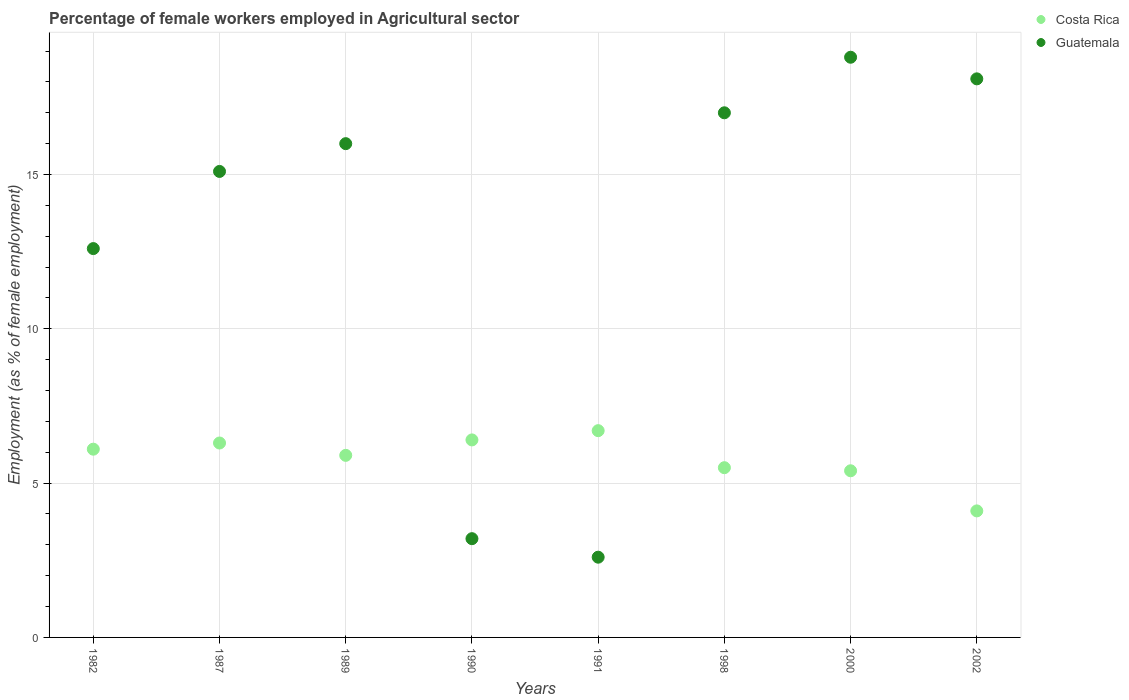What is the percentage of females employed in Agricultural sector in Costa Rica in 1982?
Your answer should be very brief. 6.1. Across all years, what is the maximum percentage of females employed in Agricultural sector in Guatemala?
Keep it short and to the point. 18.8. Across all years, what is the minimum percentage of females employed in Agricultural sector in Costa Rica?
Make the answer very short. 4.1. What is the total percentage of females employed in Agricultural sector in Costa Rica in the graph?
Your answer should be very brief. 46.4. What is the difference between the percentage of females employed in Agricultural sector in Costa Rica in 1987 and that in 1991?
Your answer should be compact. -0.4. What is the difference between the percentage of females employed in Agricultural sector in Guatemala in 1991 and the percentage of females employed in Agricultural sector in Costa Rica in 2000?
Offer a terse response. -2.8. What is the average percentage of females employed in Agricultural sector in Guatemala per year?
Your response must be concise. 12.93. In the year 1990, what is the difference between the percentage of females employed in Agricultural sector in Guatemala and percentage of females employed in Agricultural sector in Costa Rica?
Provide a succinct answer. -3.2. In how many years, is the percentage of females employed in Agricultural sector in Guatemala greater than 6 %?
Give a very brief answer. 6. What is the ratio of the percentage of females employed in Agricultural sector in Costa Rica in 1990 to that in 2000?
Provide a succinct answer. 1.19. What is the difference between the highest and the second highest percentage of females employed in Agricultural sector in Guatemala?
Offer a very short reply. 0.7. What is the difference between the highest and the lowest percentage of females employed in Agricultural sector in Guatemala?
Your answer should be compact. 16.2. In how many years, is the percentage of females employed in Agricultural sector in Costa Rica greater than the average percentage of females employed in Agricultural sector in Costa Rica taken over all years?
Keep it short and to the point. 5. Is the sum of the percentage of females employed in Agricultural sector in Costa Rica in 1991 and 2002 greater than the maximum percentage of females employed in Agricultural sector in Guatemala across all years?
Provide a succinct answer. No. Does the percentage of females employed in Agricultural sector in Guatemala monotonically increase over the years?
Offer a very short reply. No. Is the percentage of females employed in Agricultural sector in Costa Rica strictly less than the percentage of females employed in Agricultural sector in Guatemala over the years?
Make the answer very short. No. Does the graph contain grids?
Offer a very short reply. Yes. How many legend labels are there?
Your response must be concise. 2. What is the title of the graph?
Keep it short and to the point. Percentage of female workers employed in Agricultural sector. What is the label or title of the X-axis?
Keep it short and to the point. Years. What is the label or title of the Y-axis?
Make the answer very short. Employment (as % of female employment). What is the Employment (as % of female employment) in Costa Rica in 1982?
Offer a terse response. 6.1. What is the Employment (as % of female employment) in Guatemala in 1982?
Offer a terse response. 12.6. What is the Employment (as % of female employment) of Costa Rica in 1987?
Offer a very short reply. 6.3. What is the Employment (as % of female employment) of Guatemala in 1987?
Your answer should be compact. 15.1. What is the Employment (as % of female employment) in Costa Rica in 1989?
Your answer should be very brief. 5.9. What is the Employment (as % of female employment) of Guatemala in 1989?
Provide a succinct answer. 16. What is the Employment (as % of female employment) of Costa Rica in 1990?
Keep it short and to the point. 6.4. What is the Employment (as % of female employment) of Guatemala in 1990?
Ensure brevity in your answer.  3.2. What is the Employment (as % of female employment) in Costa Rica in 1991?
Ensure brevity in your answer.  6.7. What is the Employment (as % of female employment) of Guatemala in 1991?
Ensure brevity in your answer.  2.6. What is the Employment (as % of female employment) in Costa Rica in 1998?
Offer a very short reply. 5.5. What is the Employment (as % of female employment) in Costa Rica in 2000?
Make the answer very short. 5.4. What is the Employment (as % of female employment) in Guatemala in 2000?
Provide a short and direct response. 18.8. What is the Employment (as % of female employment) of Costa Rica in 2002?
Your answer should be very brief. 4.1. What is the Employment (as % of female employment) of Guatemala in 2002?
Provide a short and direct response. 18.1. Across all years, what is the maximum Employment (as % of female employment) in Costa Rica?
Offer a very short reply. 6.7. Across all years, what is the maximum Employment (as % of female employment) of Guatemala?
Provide a succinct answer. 18.8. Across all years, what is the minimum Employment (as % of female employment) in Costa Rica?
Give a very brief answer. 4.1. Across all years, what is the minimum Employment (as % of female employment) in Guatemala?
Offer a terse response. 2.6. What is the total Employment (as % of female employment) of Costa Rica in the graph?
Ensure brevity in your answer.  46.4. What is the total Employment (as % of female employment) in Guatemala in the graph?
Provide a short and direct response. 103.4. What is the difference between the Employment (as % of female employment) in Guatemala in 1982 and that in 1987?
Give a very brief answer. -2.5. What is the difference between the Employment (as % of female employment) in Costa Rica in 1982 and that in 1990?
Offer a very short reply. -0.3. What is the difference between the Employment (as % of female employment) of Guatemala in 1982 and that in 1990?
Ensure brevity in your answer.  9.4. What is the difference between the Employment (as % of female employment) in Costa Rica in 1982 and that in 1991?
Offer a terse response. -0.6. What is the difference between the Employment (as % of female employment) in Costa Rica in 1982 and that in 1998?
Offer a terse response. 0.6. What is the difference between the Employment (as % of female employment) in Costa Rica in 1982 and that in 2000?
Ensure brevity in your answer.  0.7. What is the difference between the Employment (as % of female employment) of Guatemala in 1982 and that in 2002?
Offer a terse response. -5.5. What is the difference between the Employment (as % of female employment) in Guatemala in 1987 and that in 1989?
Provide a succinct answer. -0.9. What is the difference between the Employment (as % of female employment) of Costa Rica in 1987 and that in 1990?
Your answer should be very brief. -0.1. What is the difference between the Employment (as % of female employment) of Costa Rica in 1987 and that in 1991?
Make the answer very short. -0.4. What is the difference between the Employment (as % of female employment) in Guatemala in 1987 and that in 1991?
Offer a very short reply. 12.5. What is the difference between the Employment (as % of female employment) in Costa Rica in 1987 and that in 1998?
Make the answer very short. 0.8. What is the difference between the Employment (as % of female employment) of Guatemala in 1987 and that in 1998?
Keep it short and to the point. -1.9. What is the difference between the Employment (as % of female employment) of Costa Rica in 1987 and that in 2000?
Your answer should be compact. 0.9. What is the difference between the Employment (as % of female employment) of Guatemala in 1987 and that in 2000?
Give a very brief answer. -3.7. What is the difference between the Employment (as % of female employment) in Costa Rica in 1987 and that in 2002?
Provide a succinct answer. 2.2. What is the difference between the Employment (as % of female employment) of Costa Rica in 1989 and that in 1990?
Your response must be concise. -0.5. What is the difference between the Employment (as % of female employment) in Costa Rica in 1989 and that in 1991?
Offer a very short reply. -0.8. What is the difference between the Employment (as % of female employment) of Guatemala in 1989 and that in 1991?
Keep it short and to the point. 13.4. What is the difference between the Employment (as % of female employment) in Costa Rica in 1989 and that in 2000?
Provide a short and direct response. 0.5. What is the difference between the Employment (as % of female employment) of Guatemala in 1989 and that in 2000?
Keep it short and to the point. -2.8. What is the difference between the Employment (as % of female employment) in Costa Rica in 1989 and that in 2002?
Your response must be concise. 1.8. What is the difference between the Employment (as % of female employment) of Guatemala in 1989 and that in 2002?
Make the answer very short. -2.1. What is the difference between the Employment (as % of female employment) in Costa Rica in 1990 and that in 1998?
Ensure brevity in your answer.  0.9. What is the difference between the Employment (as % of female employment) of Guatemala in 1990 and that in 1998?
Your answer should be compact. -13.8. What is the difference between the Employment (as % of female employment) of Costa Rica in 1990 and that in 2000?
Offer a terse response. 1. What is the difference between the Employment (as % of female employment) in Guatemala in 1990 and that in 2000?
Offer a terse response. -15.6. What is the difference between the Employment (as % of female employment) in Guatemala in 1990 and that in 2002?
Your answer should be compact. -14.9. What is the difference between the Employment (as % of female employment) of Costa Rica in 1991 and that in 1998?
Your answer should be compact. 1.2. What is the difference between the Employment (as % of female employment) of Guatemala in 1991 and that in 1998?
Ensure brevity in your answer.  -14.4. What is the difference between the Employment (as % of female employment) in Costa Rica in 1991 and that in 2000?
Offer a very short reply. 1.3. What is the difference between the Employment (as % of female employment) in Guatemala in 1991 and that in 2000?
Your answer should be very brief. -16.2. What is the difference between the Employment (as % of female employment) of Costa Rica in 1991 and that in 2002?
Offer a very short reply. 2.6. What is the difference between the Employment (as % of female employment) in Guatemala in 1991 and that in 2002?
Your response must be concise. -15.5. What is the difference between the Employment (as % of female employment) of Costa Rica in 1998 and that in 2000?
Your response must be concise. 0.1. What is the difference between the Employment (as % of female employment) in Guatemala in 1998 and that in 2000?
Give a very brief answer. -1.8. What is the difference between the Employment (as % of female employment) of Costa Rica in 2000 and that in 2002?
Provide a short and direct response. 1.3. What is the difference between the Employment (as % of female employment) in Costa Rica in 1982 and the Employment (as % of female employment) in Guatemala in 1987?
Your answer should be compact. -9. What is the difference between the Employment (as % of female employment) of Costa Rica in 1982 and the Employment (as % of female employment) of Guatemala in 1989?
Give a very brief answer. -9.9. What is the difference between the Employment (as % of female employment) of Costa Rica in 1982 and the Employment (as % of female employment) of Guatemala in 1991?
Offer a very short reply. 3.5. What is the difference between the Employment (as % of female employment) of Costa Rica in 1982 and the Employment (as % of female employment) of Guatemala in 1998?
Your answer should be very brief. -10.9. What is the difference between the Employment (as % of female employment) in Costa Rica in 1982 and the Employment (as % of female employment) in Guatemala in 2000?
Your response must be concise. -12.7. What is the difference between the Employment (as % of female employment) of Costa Rica in 1982 and the Employment (as % of female employment) of Guatemala in 2002?
Make the answer very short. -12. What is the difference between the Employment (as % of female employment) in Costa Rica in 1987 and the Employment (as % of female employment) in Guatemala in 1989?
Your answer should be very brief. -9.7. What is the difference between the Employment (as % of female employment) in Costa Rica in 1987 and the Employment (as % of female employment) in Guatemala in 1990?
Your response must be concise. 3.1. What is the difference between the Employment (as % of female employment) of Costa Rica in 1989 and the Employment (as % of female employment) of Guatemala in 1991?
Give a very brief answer. 3.3. What is the difference between the Employment (as % of female employment) of Costa Rica in 1990 and the Employment (as % of female employment) of Guatemala in 2000?
Provide a short and direct response. -12.4. What is the difference between the Employment (as % of female employment) of Costa Rica in 1990 and the Employment (as % of female employment) of Guatemala in 2002?
Keep it short and to the point. -11.7. What is the difference between the Employment (as % of female employment) in Costa Rica in 1991 and the Employment (as % of female employment) in Guatemala in 1998?
Keep it short and to the point. -10.3. What is the average Employment (as % of female employment) in Guatemala per year?
Ensure brevity in your answer.  12.93. In the year 1987, what is the difference between the Employment (as % of female employment) of Costa Rica and Employment (as % of female employment) of Guatemala?
Keep it short and to the point. -8.8. In the year 1991, what is the difference between the Employment (as % of female employment) in Costa Rica and Employment (as % of female employment) in Guatemala?
Give a very brief answer. 4.1. In the year 1998, what is the difference between the Employment (as % of female employment) of Costa Rica and Employment (as % of female employment) of Guatemala?
Give a very brief answer. -11.5. What is the ratio of the Employment (as % of female employment) in Costa Rica in 1982 to that in 1987?
Provide a short and direct response. 0.97. What is the ratio of the Employment (as % of female employment) of Guatemala in 1982 to that in 1987?
Your answer should be very brief. 0.83. What is the ratio of the Employment (as % of female employment) in Costa Rica in 1982 to that in 1989?
Ensure brevity in your answer.  1.03. What is the ratio of the Employment (as % of female employment) of Guatemala in 1982 to that in 1989?
Ensure brevity in your answer.  0.79. What is the ratio of the Employment (as % of female employment) of Costa Rica in 1982 to that in 1990?
Provide a succinct answer. 0.95. What is the ratio of the Employment (as % of female employment) in Guatemala in 1982 to that in 1990?
Provide a succinct answer. 3.94. What is the ratio of the Employment (as % of female employment) of Costa Rica in 1982 to that in 1991?
Your response must be concise. 0.91. What is the ratio of the Employment (as % of female employment) in Guatemala in 1982 to that in 1991?
Give a very brief answer. 4.85. What is the ratio of the Employment (as % of female employment) in Costa Rica in 1982 to that in 1998?
Give a very brief answer. 1.11. What is the ratio of the Employment (as % of female employment) of Guatemala in 1982 to that in 1998?
Offer a terse response. 0.74. What is the ratio of the Employment (as % of female employment) in Costa Rica in 1982 to that in 2000?
Give a very brief answer. 1.13. What is the ratio of the Employment (as % of female employment) in Guatemala in 1982 to that in 2000?
Provide a short and direct response. 0.67. What is the ratio of the Employment (as % of female employment) in Costa Rica in 1982 to that in 2002?
Give a very brief answer. 1.49. What is the ratio of the Employment (as % of female employment) of Guatemala in 1982 to that in 2002?
Your answer should be very brief. 0.7. What is the ratio of the Employment (as % of female employment) of Costa Rica in 1987 to that in 1989?
Your answer should be compact. 1.07. What is the ratio of the Employment (as % of female employment) of Guatemala in 1987 to that in 1989?
Keep it short and to the point. 0.94. What is the ratio of the Employment (as % of female employment) in Costa Rica in 1987 to that in 1990?
Your answer should be very brief. 0.98. What is the ratio of the Employment (as % of female employment) in Guatemala in 1987 to that in 1990?
Keep it short and to the point. 4.72. What is the ratio of the Employment (as % of female employment) in Costa Rica in 1987 to that in 1991?
Provide a succinct answer. 0.94. What is the ratio of the Employment (as % of female employment) of Guatemala in 1987 to that in 1991?
Give a very brief answer. 5.81. What is the ratio of the Employment (as % of female employment) in Costa Rica in 1987 to that in 1998?
Offer a terse response. 1.15. What is the ratio of the Employment (as % of female employment) of Guatemala in 1987 to that in 1998?
Ensure brevity in your answer.  0.89. What is the ratio of the Employment (as % of female employment) of Guatemala in 1987 to that in 2000?
Offer a terse response. 0.8. What is the ratio of the Employment (as % of female employment) in Costa Rica in 1987 to that in 2002?
Give a very brief answer. 1.54. What is the ratio of the Employment (as % of female employment) in Guatemala in 1987 to that in 2002?
Offer a terse response. 0.83. What is the ratio of the Employment (as % of female employment) in Costa Rica in 1989 to that in 1990?
Give a very brief answer. 0.92. What is the ratio of the Employment (as % of female employment) of Costa Rica in 1989 to that in 1991?
Ensure brevity in your answer.  0.88. What is the ratio of the Employment (as % of female employment) of Guatemala in 1989 to that in 1991?
Make the answer very short. 6.15. What is the ratio of the Employment (as % of female employment) of Costa Rica in 1989 to that in 1998?
Ensure brevity in your answer.  1.07. What is the ratio of the Employment (as % of female employment) of Costa Rica in 1989 to that in 2000?
Your response must be concise. 1.09. What is the ratio of the Employment (as % of female employment) in Guatemala in 1989 to that in 2000?
Make the answer very short. 0.85. What is the ratio of the Employment (as % of female employment) in Costa Rica in 1989 to that in 2002?
Ensure brevity in your answer.  1.44. What is the ratio of the Employment (as % of female employment) of Guatemala in 1989 to that in 2002?
Offer a terse response. 0.88. What is the ratio of the Employment (as % of female employment) of Costa Rica in 1990 to that in 1991?
Offer a terse response. 0.96. What is the ratio of the Employment (as % of female employment) in Guatemala in 1990 to that in 1991?
Keep it short and to the point. 1.23. What is the ratio of the Employment (as % of female employment) in Costa Rica in 1990 to that in 1998?
Ensure brevity in your answer.  1.16. What is the ratio of the Employment (as % of female employment) of Guatemala in 1990 to that in 1998?
Your answer should be compact. 0.19. What is the ratio of the Employment (as % of female employment) in Costa Rica in 1990 to that in 2000?
Your answer should be compact. 1.19. What is the ratio of the Employment (as % of female employment) of Guatemala in 1990 to that in 2000?
Offer a very short reply. 0.17. What is the ratio of the Employment (as % of female employment) in Costa Rica in 1990 to that in 2002?
Your answer should be very brief. 1.56. What is the ratio of the Employment (as % of female employment) of Guatemala in 1990 to that in 2002?
Your answer should be very brief. 0.18. What is the ratio of the Employment (as % of female employment) in Costa Rica in 1991 to that in 1998?
Your answer should be compact. 1.22. What is the ratio of the Employment (as % of female employment) in Guatemala in 1991 to that in 1998?
Provide a short and direct response. 0.15. What is the ratio of the Employment (as % of female employment) in Costa Rica in 1991 to that in 2000?
Keep it short and to the point. 1.24. What is the ratio of the Employment (as % of female employment) of Guatemala in 1991 to that in 2000?
Your answer should be very brief. 0.14. What is the ratio of the Employment (as % of female employment) of Costa Rica in 1991 to that in 2002?
Make the answer very short. 1.63. What is the ratio of the Employment (as % of female employment) of Guatemala in 1991 to that in 2002?
Offer a very short reply. 0.14. What is the ratio of the Employment (as % of female employment) of Costa Rica in 1998 to that in 2000?
Provide a short and direct response. 1.02. What is the ratio of the Employment (as % of female employment) of Guatemala in 1998 to that in 2000?
Your answer should be compact. 0.9. What is the ratio of the Employment (as % of female employment) in Costa Rica in 1998 to that in 2002?
Offer a very short reply. 1.34. What is the ratio of the Employment (as % of female employment) in Guatemala in 1998 to that in 2002?
Keep it short and to the point. 0.94. What is the ratio of the Employment (as % of female employment) in Costa Rica in 2000 to that in 2002?
Keep it short and to the point. 1.32. What is the ratio of the Employment (as % of female employment) of Guatemala in 2000 to that in 2002?
Your response must be concise. 1.04. What is the difference between the highest and the second highest Employment (as % of female employment) of Guatemala?
Ensure brevity in your answer.  0.7. What is the difference between the highest and the lowest Employment (as % of female employment) in Costa Rica?
Keep it short and to the point. 2.6. What is the difference between the highest and the lowest Employment (as % of female employment) of Guatemala?
Give a very brief answer. 16.2. 